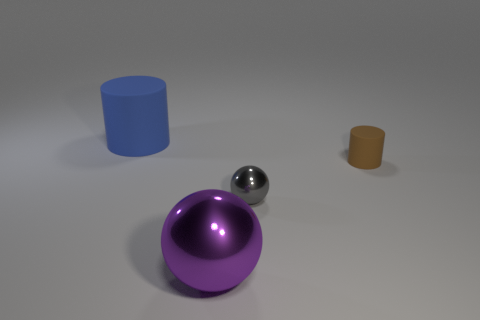What is the shape of the metallic object that is behind the big purple thing?
Offer a very short reply. Sphere. Is there a large block?
Your answer should be compact. No. There is a shiny thing that is in front of the small object that is in front of the cylinder that is on the right side of the purple metallic sphere; what is its shape?
Give a very brief answer. Sphere. What number of small cylinders are right of the brown thing?
Offer a very short reply. 0. Is the cylinder that is right of the large blue cylinder made of the same material as the gray sphere?
Offer a very short reply. No. There is a large object in front of the matte cylinder that is in front of the blue rubber cylinder; how many metallic spheres are right of it?
Keep it short and to the point. 1. There is a rubber thing that is behind the small brown cylinder; what is its color?
Your response must be concise. Blue. There is another rubber thing that is the same shape as the blue object; what size is it?
Provide a short and direct response. Small. There is a cylinder behind the brown cylinder that is to the right of the cylinder on the left side of the tiny matte object; what is its material?
Provide a succinct answer. Rubber. Is the number of gray metal objects that are in front of the tiny cylinder greater than the number of large shiny objects behind the gray metal ball?
Give a very brief answer. Yes. 